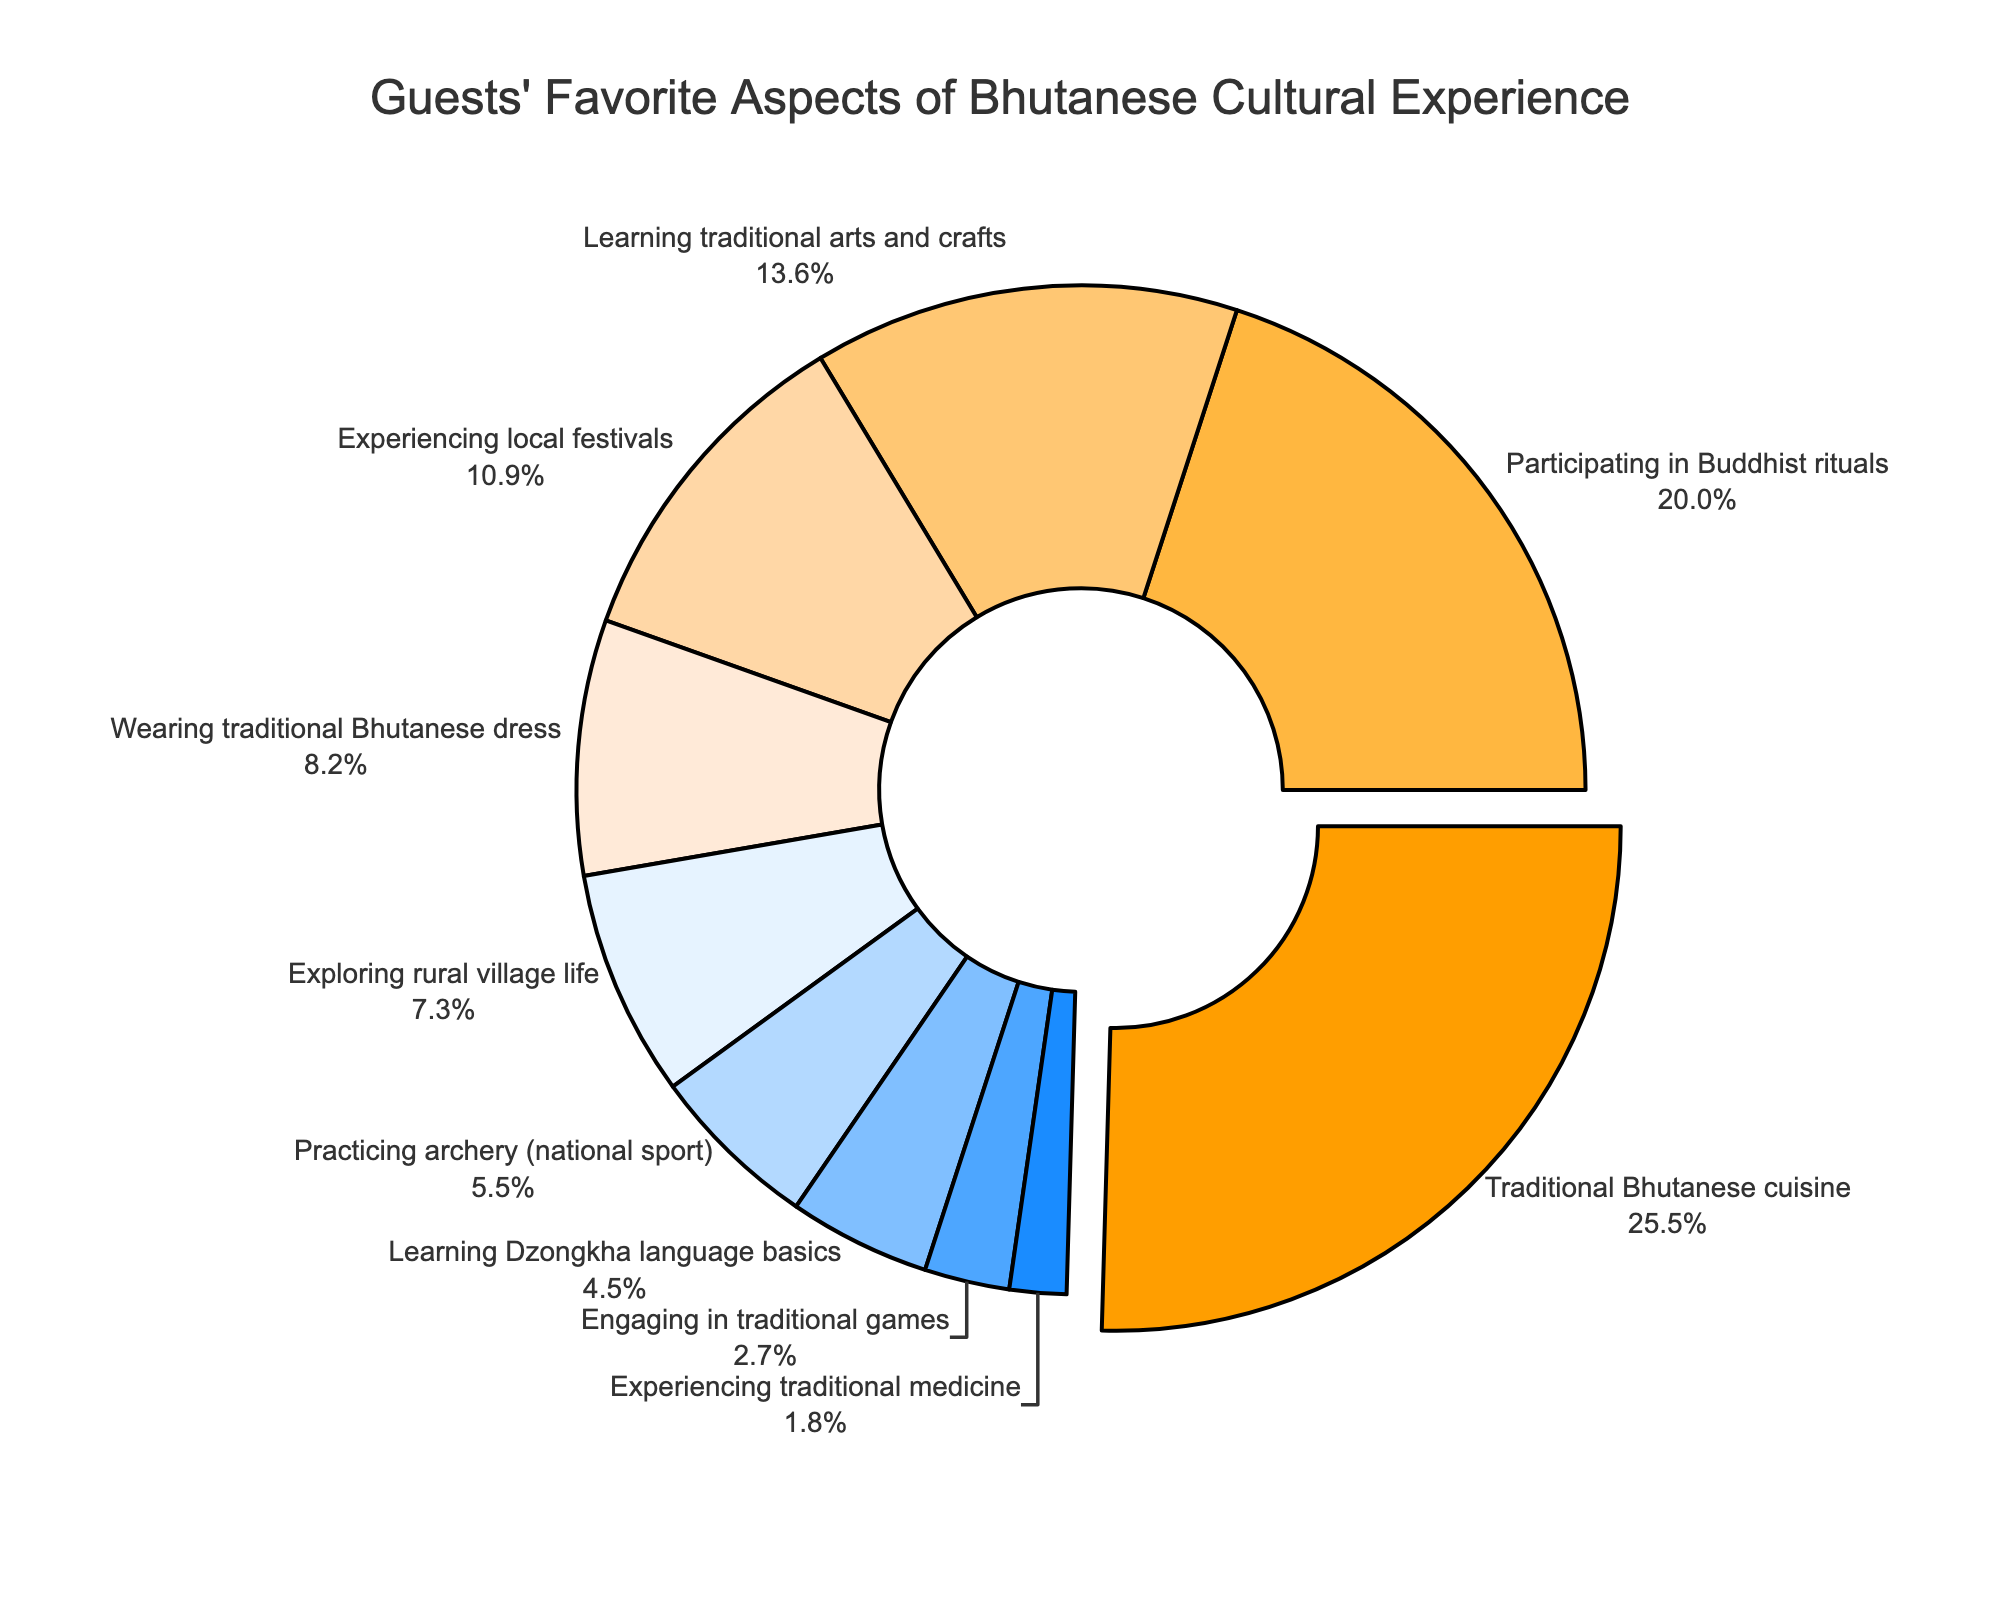what is the most favorite aspect of the Bhutanese cultural experience? By looking at the segments, the Traditional Bhutanese cuisine has the largest segment, indicating it is the favorite aspect among guests
Answer: Traditional Bhutanese cuisine Which aspect has a segment pulled out from the pie chart? The segment representing Traditional Bhutanese cuisine is slightly pulled out from the pie chart, highlighting it as the most favorite aspect
Answer: Traditional Bhutanese cuisine How much more percentage does Learning traditional arts and crafts have compared to Practicing archery? Learning traditional arts and crafts has 15%, while Practicing archery has 6%. The difference is calculated as 15% - 6% = 9%
Answer: 9% Which aspects have percentages less than 10%? By checking the pie chart, the aspects with less than 10% are Wearing traditional Bhutanese dress (9%), Exploring rural village life (8%), Practicing archery (6%), Learning Dzongkha language basics (5%), Engaging in traditional games (3%), and Experiencing traditional medicine (2%)
Answer: Wearing traditional Bhutanese dress, Exploring rural village life, Practicing archery, Learning Dzongkha language basics, Engaging in traditional games, Experiencing traditional medicine Which aspects combined make up more than 50% of the guests' preferences? Adding the percentages of the largest segments: Traditional Bhutanese cuisine (28%) + Participating in Buddhist rituals (22%) gives 50%. Any additional aspect would make it above 50%, but on its own, Traditional Bhutanese cuisine and Participating in Buddhist rituals cumulatively account for 50%
Answer: Traditional Bhutanese cuisine and Participating in Buddhist rituals What is the total percentage of aspects related to learning activities (Learning traditional arts and crafts, Learning Dzongkha language basics)? Add the percentages of Learning traditional arts and crafts (15%) and Learning Dzongkha language basics (5%) = 15% + 5% = 20%
Answer: 20% Which has a larger percentage: Experiencing local festivals or Wearing traditional Bhutanese dress? Comparing their segments, Experiencing local festivals has 12% and Wearing traditional Bhutanese dress has 9%, so Experiencing local festivals has a larger percentage
Answer: Experiencing local festivals How does the percentage of Experiencing rural village life compare to Practicing archery? The segment for Experiencing rural village life shows 8%, and Practicing archery shows 6%, so Experiencing rural village life has a larger percentage
Answer: Experiencing rural village life What is the cumulative percentage of less common activities (Practicing archery, Engaging in traditional games, Experiencing traditional medicine)? Sum the percentages: Practicing archery (6%), Engaging in traditional games (3%), Experiencing traditional medicine (2%) = 6% + 3% + 2% = 11%
Answer: 11% What percentage prefers activities related to traditional competitions (Practicing archery, Engaging in traditional games)? Add the relevant percentages: Practicing archery (6%), Engaging in traditional games (3%) = 6% + 3% = 9%
Answer: 9% 